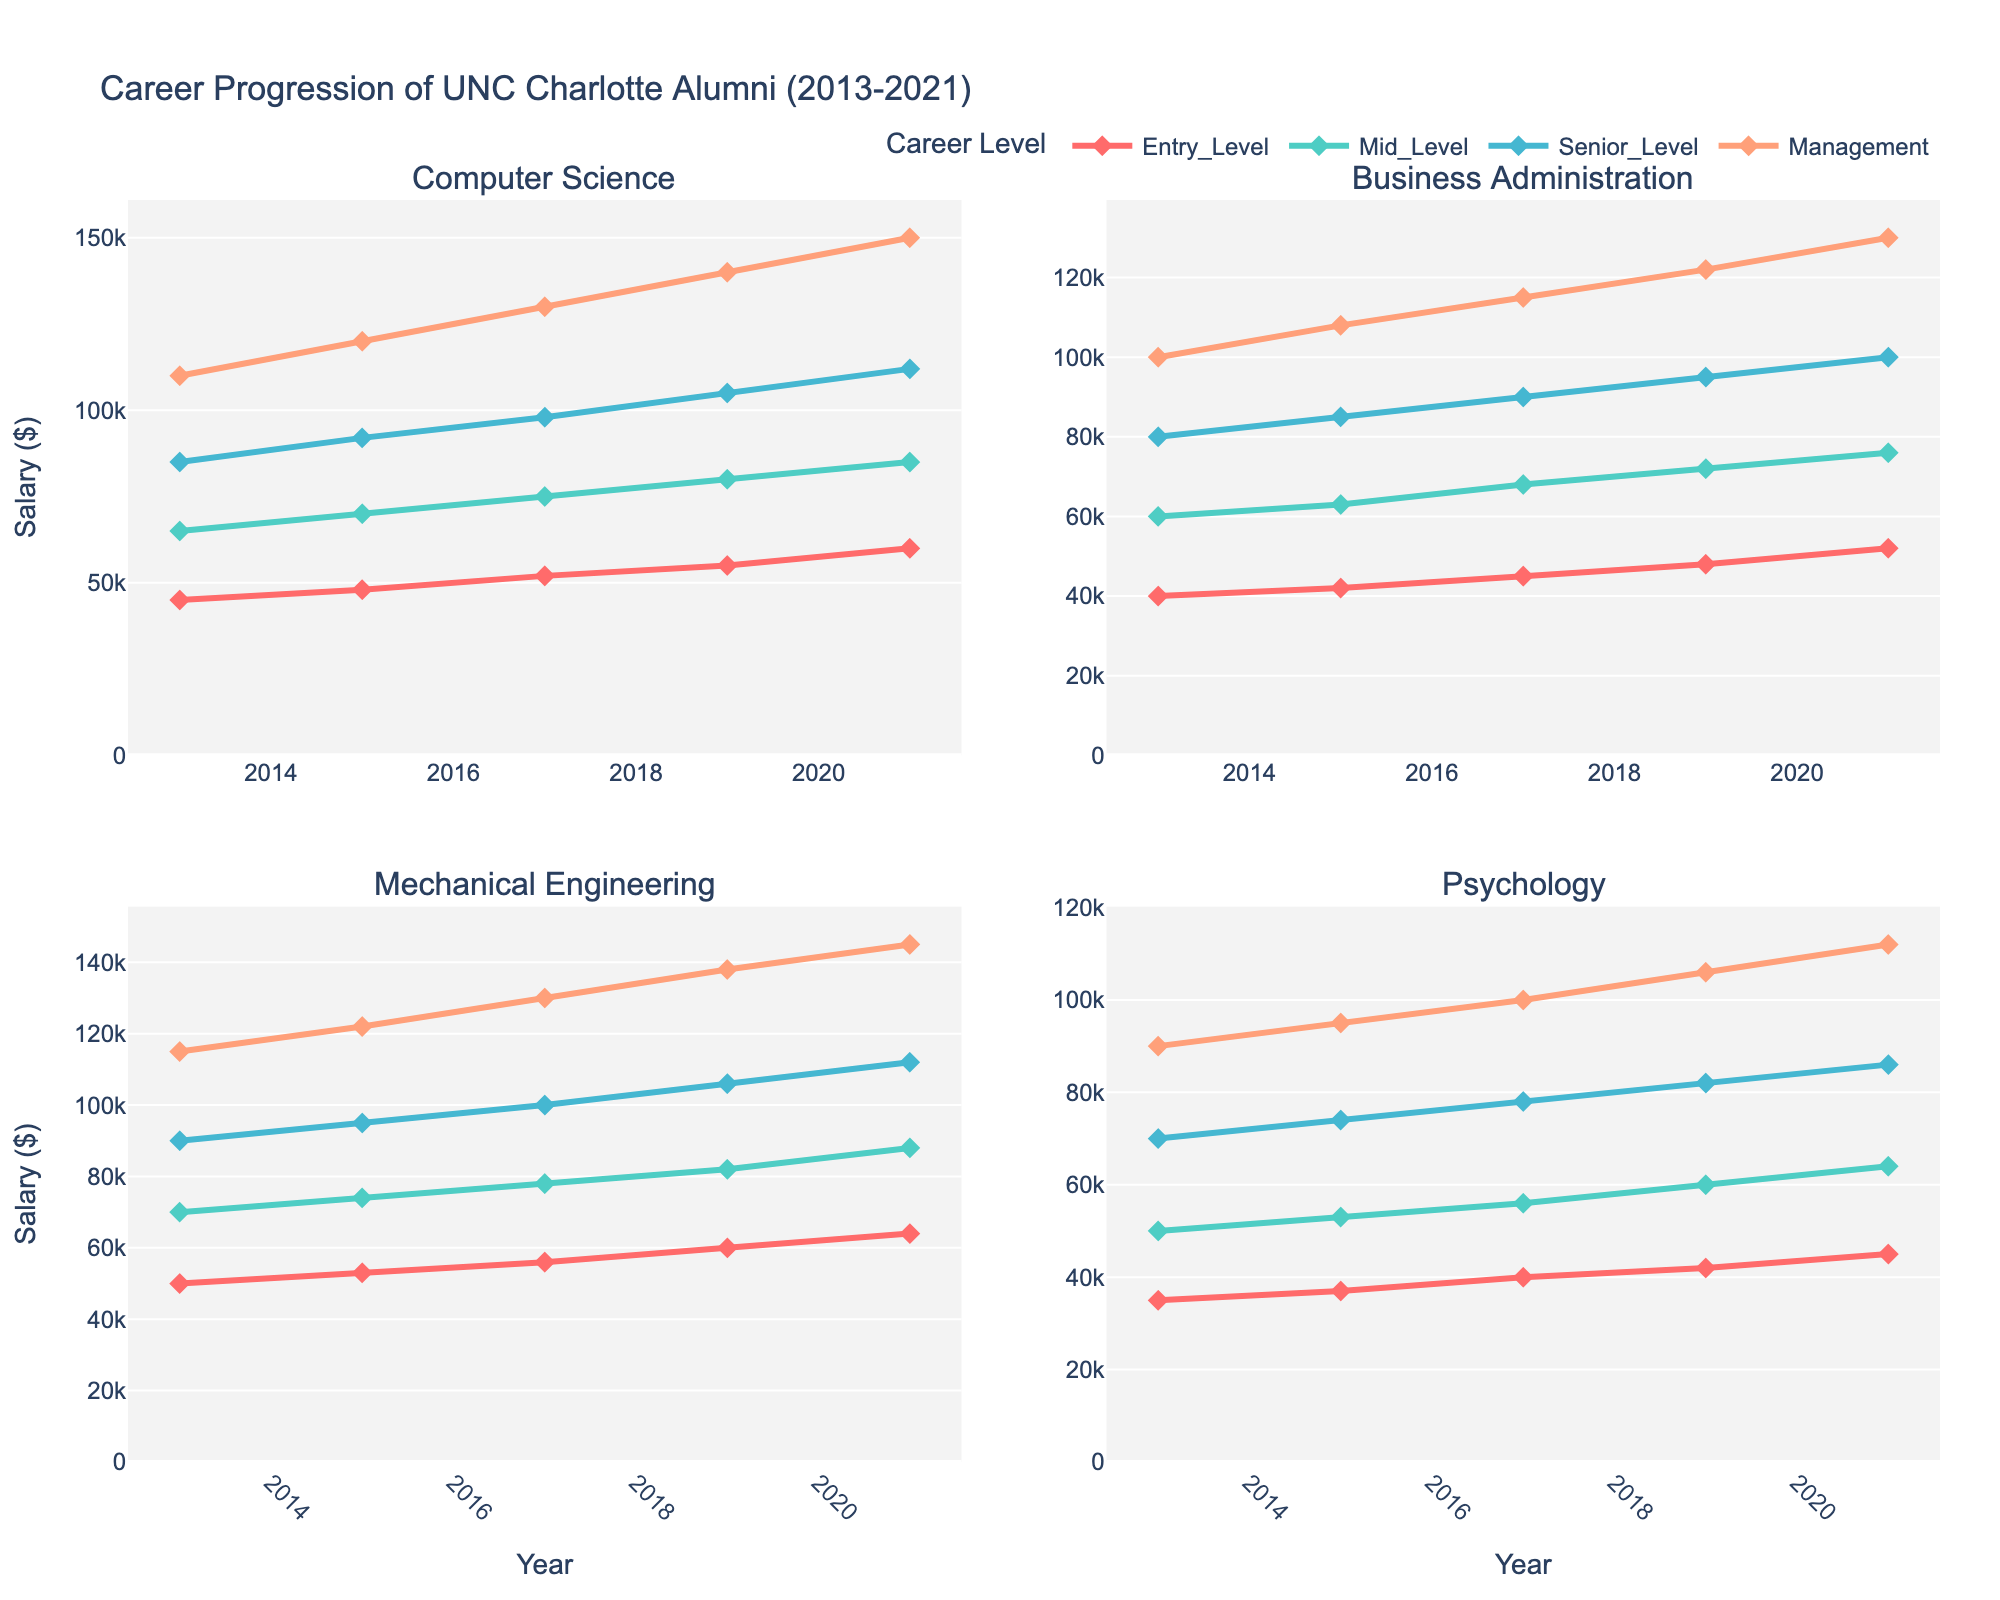What's the title of the plot? The title is often located at the top of the plot. In this case, it reads "Market Share Distribution of Steel Products (2018-2022)"
Answer: Market Share Distribution of Steel Products (2018-2022) Which industry segment had the highest market share in the "Automotive" category in 2022? Look at the "Automotive" subplot and find the 2022 data point. It shows the value for the "Automotive" category.
Answer: 44% How did the market share for "Construction" in the "Energy" industry change from 2018 to 2022? Track the "Construction" data points in the subplot titled "Energy" from 2018 to 2022. There is a decrease from 18% in 2018 to 14% in 2022.
Answer: Decreased by 4% Which product category had consistently the highest market share in the "Consumer Goods" industry from 2018 to 2022? In the "Consumer Goods" subplot, observe the data points for each category over the years. The "Consumer Goods" line remains at 45% throughout these years.
Answer: Consumer Goods Between 2019 and 2021, which category showed the most significant increase in market share in the "Construction" industry? Look at the "Construction" subplot. Track the data points between 2019 and 2021 for all categories. "Construction" increased from 37% to 38%. "Energy" showed the highest increase from 16% to 18%.
Answer: Energy What is the overall trend of the "Machinery" category in the "Machinery" industry subplot from 2018 to 2022? Track the line representing the "Machinery" category in the "Machinery" industry subplot. The line increases from 32% in 2018 to 36% in 2022, indicating a consistent upward trend.
Answer: Upward trend Which industry had the least variation in the "Automotive" category from 2018 to 2022? Compare the "Automotive" category line across all subplots. The "Consumer Goods" industry shows the least variation, remaining between 20-24%.
Answer: Consumer Goods In 2020, did the market share of the "Energy" category in the "Energy" subplot increase or decrease compared to 2019? Look at the "Energy" category line in the "Energy" subplot and compare the values for 2019 and 2020. It increased from 36% to 37%.
Answer: Increased Considering the "Automotive" category, which industry had the highest increase in market share from 2019 to 2022? Look at the "Automotive" category lines across all subplots and compare the difference in values from 2019 to 2022. The "Automotive" industry itself increased from 42% to 44%.
Answer: Automotive 